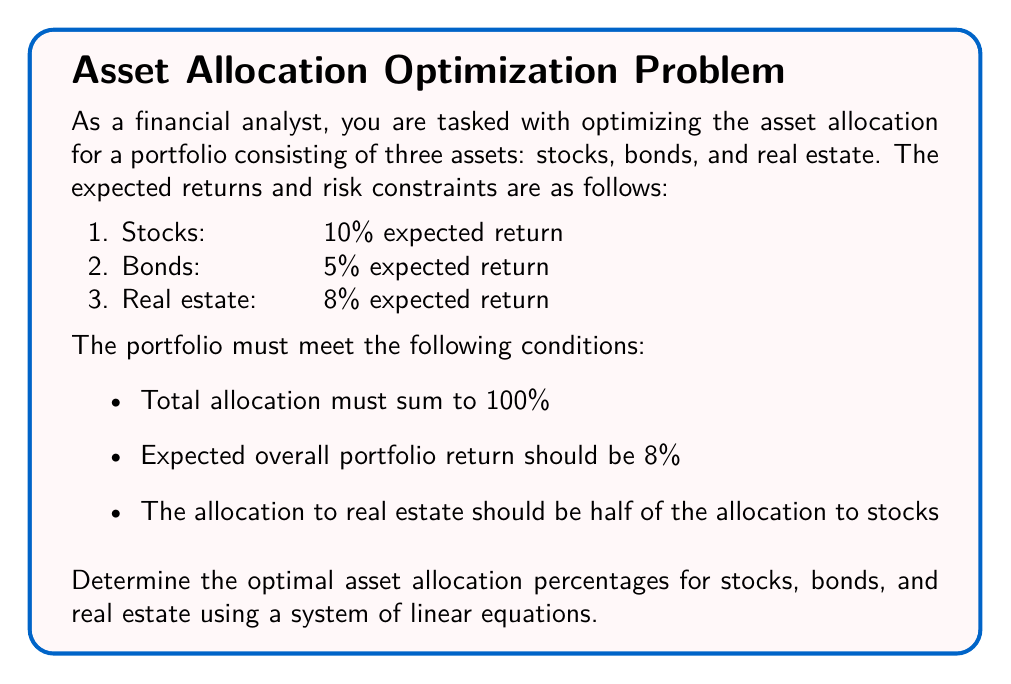Teach me how to tackle this problem. Let's solve this problem step by step using a system of linear equations:

1. Define variables:
   Let $x$ = allocation to stocks
   Let $y$ = allocation to bonds
   Let $z$ = allocation to real estate

2. Set up the system of linear equations based on the given conditions:

   Equation 1 (total allocation): 
   $$x + y + z = 1$$ (representing 100%)

   Equation 2 (expected return):
   $$0.10x + 0.05y + 0.08z = 0.08$$ (8% overall return)

   Equation 3 (real estate allocation):
   $$z = 0.5x$$ (real estate is half of stocks)

3. Substitute Equation 3 into Equations 1 and 2:

   Equation 1: $x + y + 0.5x = 1$
               $1.5x + y = 1$

   Equation 2: $0.10x + 0.05y + 0.08(0.5x) = 0.08$
               $0.10x + 0.05y + 0.04x = 0.08$
               $0.14x + 0.05y = 0.08$

4. Now we have a system of two equations with two unknowns:

   $1.5x + y = 1$
   $0.14x + 0.05y = 0.08$

5. Multiply the second equation by 20 to eliminate decimals:

   $1.5x + y = 1$
   $2.8x + y = 1.6$

6. Subtract the first equation from the second:

   $1.3x = 0.6$

7. Solve for x:

   $x = 0.6 / 1.3 = 0.4615384615$

8. Substitute x back into the first equation to solve for y:

   $1.5(0.4615384615) + y = 1$
   $0.6923076923 + y = 1$
   $y = 1 - 0.6923076923 = 0.3076923077$

9. Calculate z using Equation 3:

   $z = 0.5x = 0.5(0.4615384615) = 0.2307692308$

10. Convert to percentages:

    Stocks (x): 46.15%
    Bonds (y): 30.77%
    Real Estate (z): 23.08%
Answer: Stocks: 46.15%, Bonds: 30.77%, Real Estate: 23.08% 